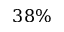<formula> <loc_0><loc_0><loc_500><loc_500>3 8 \%</formula> 